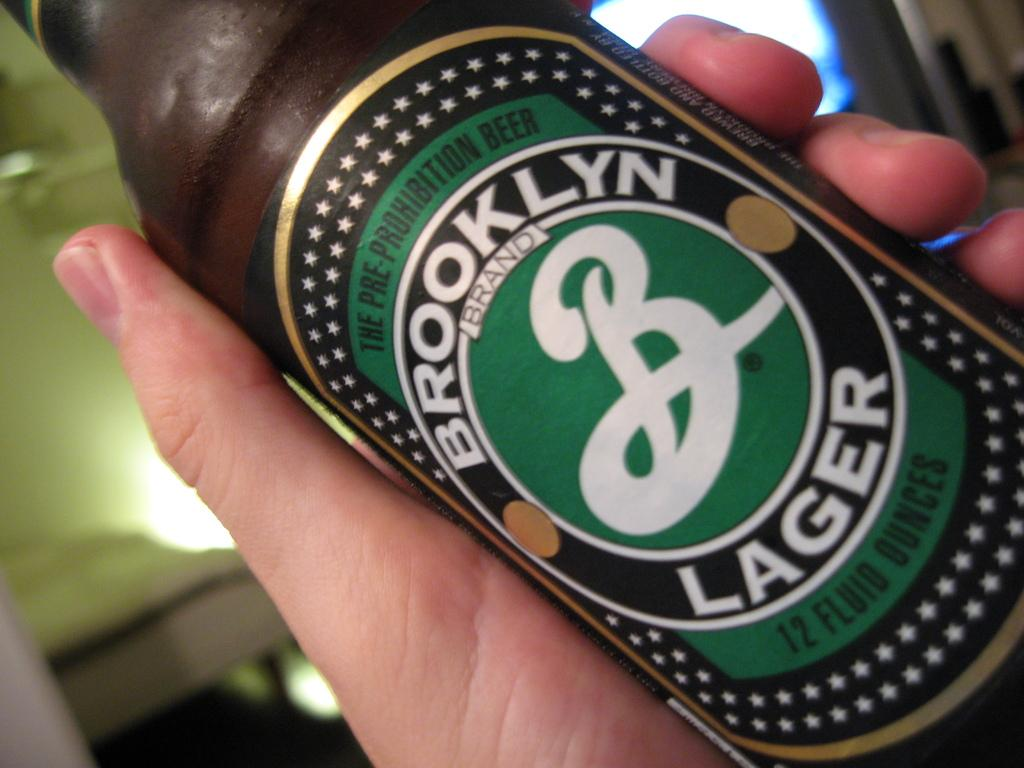Who or what is present in the image? There is a person in the image. What is the person holding in the image? The person is holding a wine bottle. Can you describe the wine bottle in more detail? The wine bottle has a label on it. What does the label say? The label has the name "Brooklyn Lager" on it. What type of soup is being served in the image? There is no soup present in the image. Is the person wearing a suit in the image? The provided facts do not mention the person's attire, so we cannot determine if they are wearing a suit or not. 